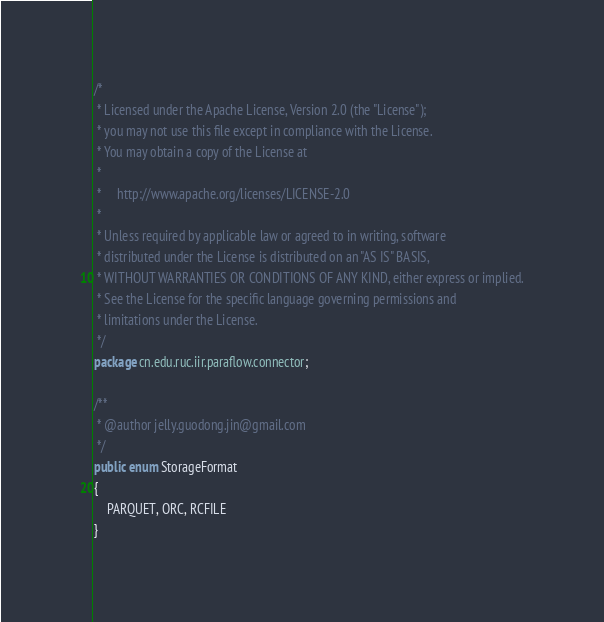Convert code to text. <code><loc_0><loc_0><loc_500><loc_500><_Java_>/*
 * Licensed under the Apache License, Version 2.0 (the "License");
 * you may not use this file except in compliance with the License.
 * You may obtain a copy of the License at
 *
 *     http://www.apache.org/licenses/LICENSE-2.0
 *
 * Unless required by applicable law or agreed to in writing, software
 * distributed under the License is distributed on an "AS IS" BASIS,
 * WITHOUT WARRANTIES OR CONDITIONS OF ANY KIND, either express or implied.
 * See the License for the specific language governing permissions and
 * limitations under the License.
 */
package cn.edu.ruc.iir.paraflow.connector;

/**
 * @author jelly.guodong.jin@gmail.com
 */
public enum StorageFormat
{
    PARQUET, ORC, RCFILE
}
</code> 